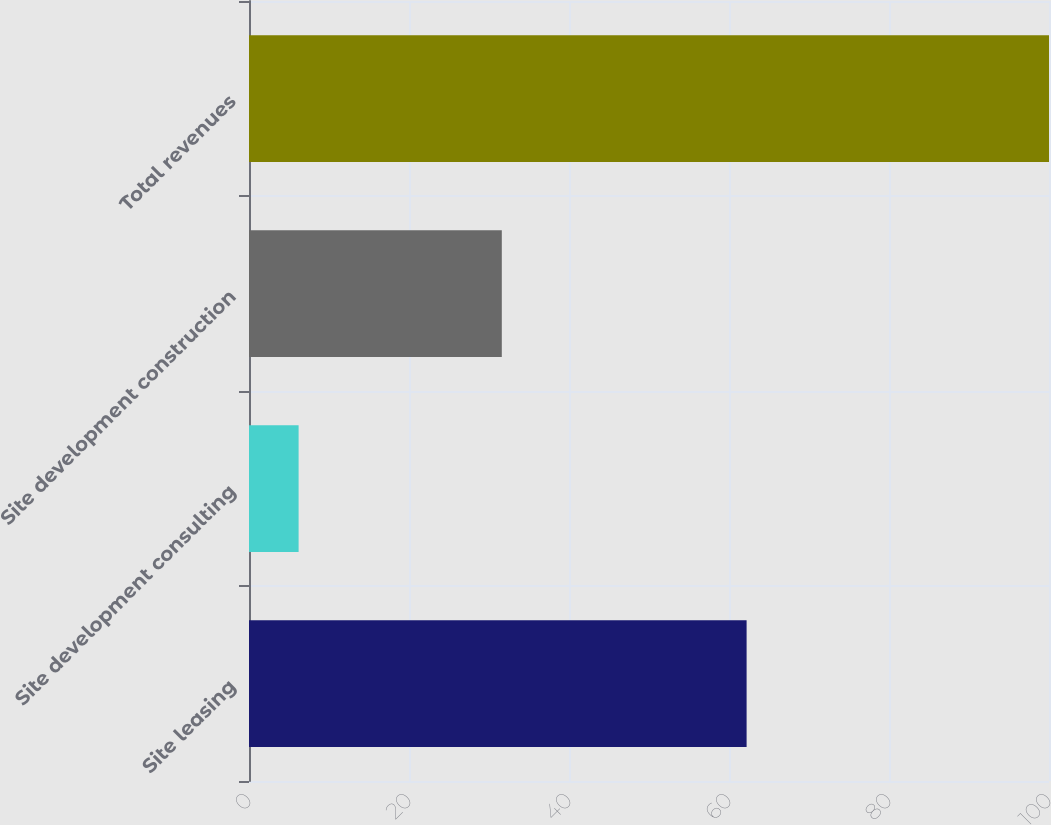Convert chart. <chart><loc_0><loc_0><loc_500><loc_500><bar_chart><fcel>Site leasing<fcel>Site development consulting<fcel>Site development construction<fcel>Total revenues<nl><fcel>62.2<fcel>6.2<fcel>31.6<fcel>100<nl></chart> 